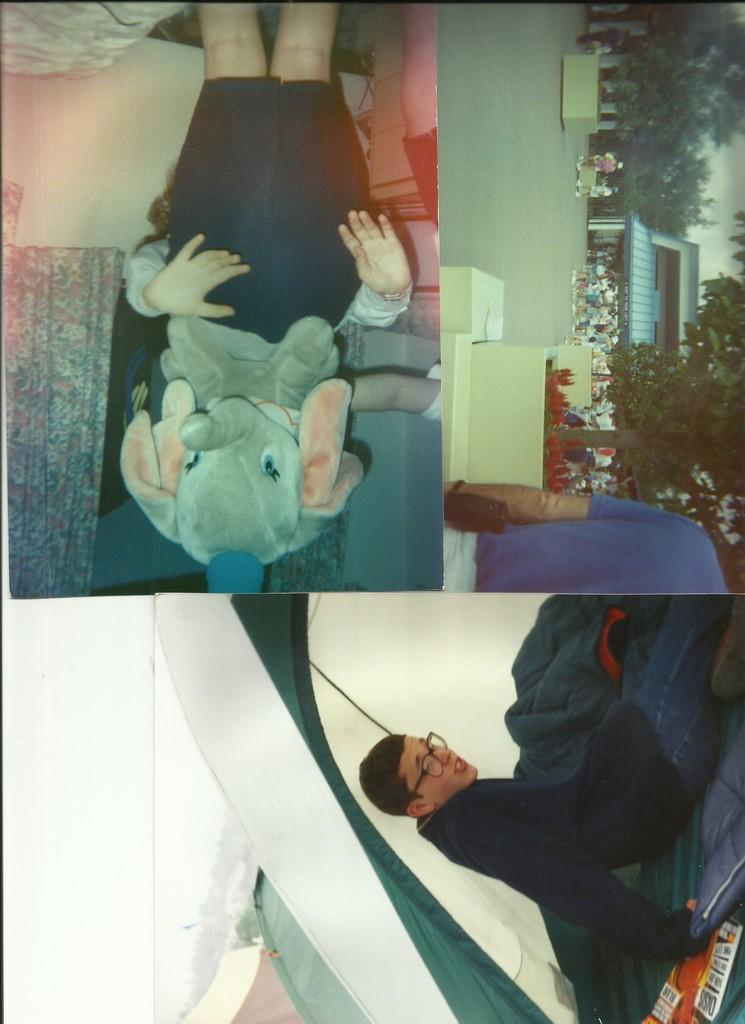Describe this image in one or two sentences. This image is consists of a collage of photos. 